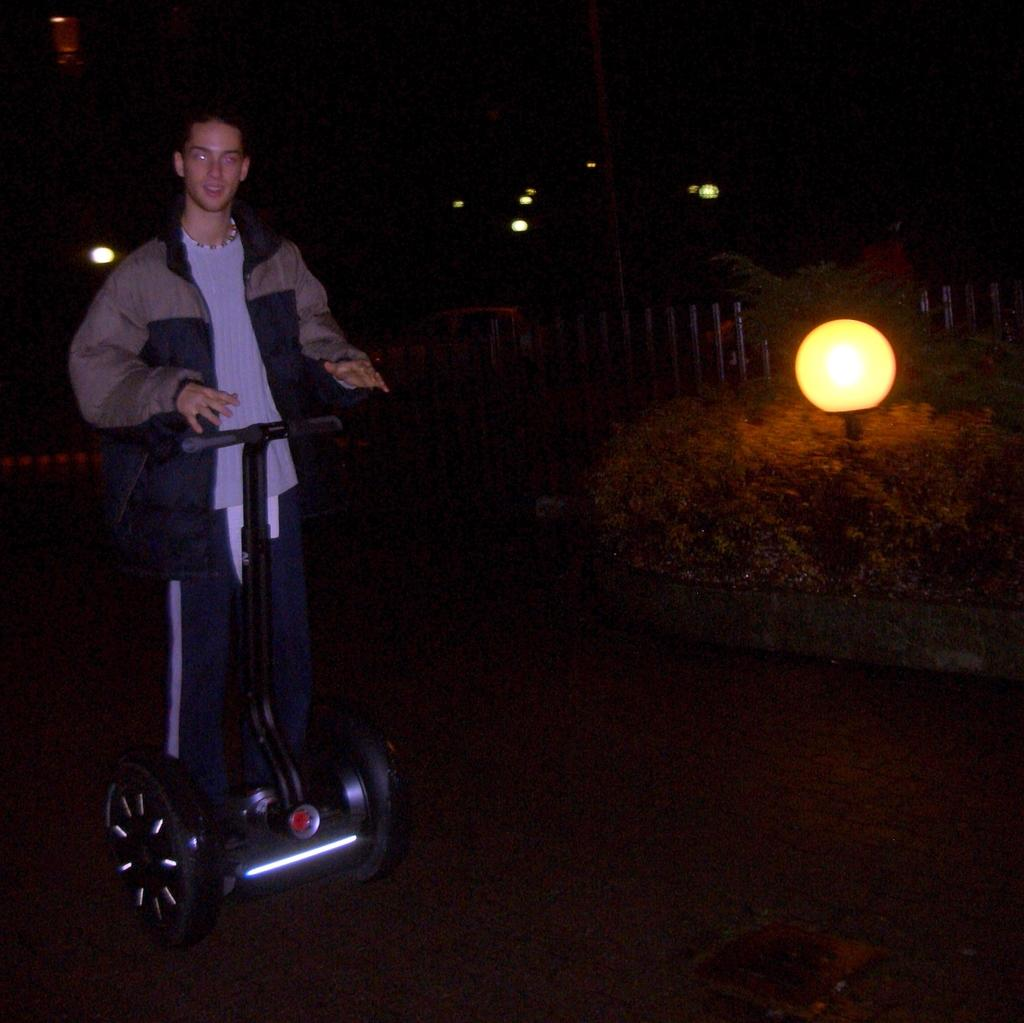What is the main subject on the left side of the image? There is a person on a scooter on the left side of the image. What type of vegetation is on the right side of the image? There are plants on the right side of the image. Can you describe the lighting conditions in the image? There is light visible in the image, but the background is dark. What can be seen in the background of the image? There are lights in the background of the image. What type of shoes is the person wearing in the image? There is no information about the person's shoes in the image. What smell can be detected in the image? There is no information about any smell in the image. 